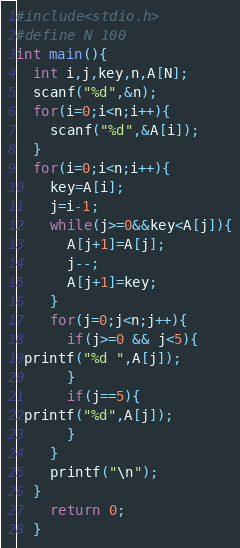<code> <loc_0><loc_0><loc_500><loc_500><_C_>#include<stdio.h>
#define N 100
int main(){
  int i,j,key,n,A[N];
  scanf("%d",&n);
  for(i=0;i<n;i++){
    scanf("%d",&A[i]);
  }
  for(i=0;i<n;i++){
    key=A[i];
    j=i-1;
    while(j>=0&&key<A[j]){
      A[j+1]=A[j];
      j--;
      A[j+1]=key;
    }
    for(j=0;j<n;j++){
      if(j>=0 && j<5){
 printf("%d ",A[j]);
      }
      if(j==5){
 printf("%d",A[j]);
      }
    }
    printf("\n");
  }
    return 0;
  }</code> 